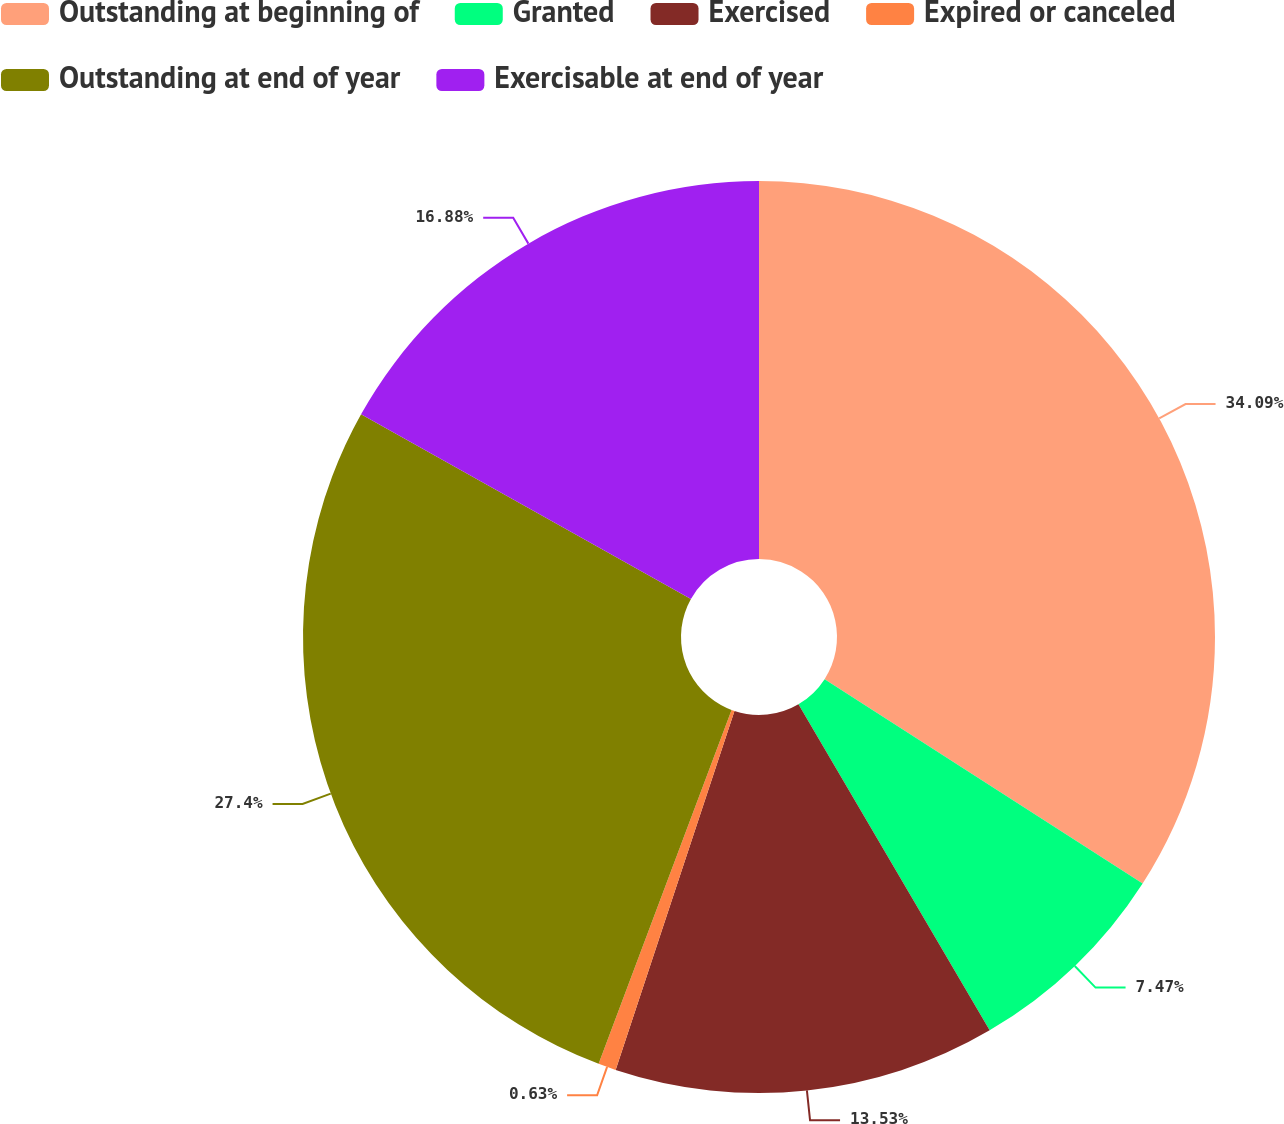Convert chart. <chart><loc_0><loc_0><loc_500><loc_500><pie_chart><fcel>Outstanding at beginning of<fcel>Granted<fcel>Exercised<fcel>Expired or canceled<fcel>Outstanding at end of year<fcel>Exercisable at end of year<nl><fcel>34.09%<fcel>7.47%<fcel>13.53%<fcel>0.63%<fcel>27.4%<fcel>16.88%<nl></chart> 